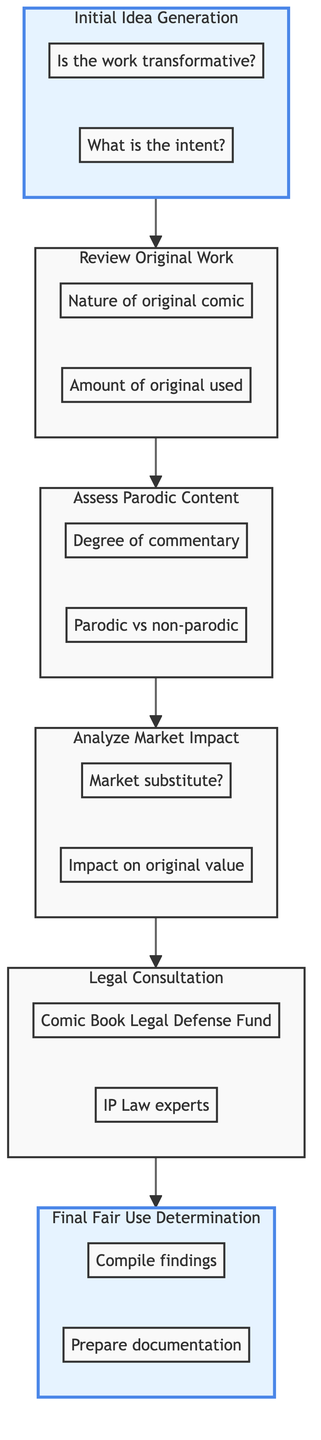What is the first stage in the fair use determination? The first stage is clearly labeled as "Initial Idea Generation" in the diagram, indicated by the arrow pointing to the next stage.
Answer: Initial Idea Generation How many stages are included in the diagram? The diagram includes six distinct stages, as indicated by the nodes connected by arrows, leading from the Initial Idea Generation to the Final Fair Use Determination.
Answer: Six What follows after the "Assess Parodic Content" stage? Based on the flow of the diagram, "Analyze Market Impact" directly follows "Assess Parodic Content", as indicated by the arrow connecting these two stages.
Answer: Analyze Market Impact Which stage includes evaluating the economic effect on the original work? The stage focused on evaluating the economic effect is "Analyze Market Impact", as it directly addresses the economic implications related to the parody work.
Answer: Analyze Market Impact What is the key question identified in the "Legal Consultation" stage? The key question pertaining to "Legal Consultation" is not explicitly stated, but it includes organizations like "Comic Book Legal Defense Fund" and professionals like "IP Law experts" which are critical in this stage.
Answer: Comic Book Legal Defense Fund What is one of the resources mentioned in the "Initial Idea Generation" stage? The resources listed under the "Initial Idea Generation" stage include insights from "Peter David" regarding parody in comic books, which is crucial for understanding this stage.
Answer: Peter David's insights What is compiled in the final stage of fair use determination? The final stage, labeled "Final Fair Use Determination", states that findings from all earlier steps need to be compiled, which is necessary for concluding the fair use analysis.
Answer: Compile findings Which sub-stage discusses the degree of comment or critique? The sub-stage that discusses the degree of comment or critique is "Assess Parodic Content", where it evaluates how the parody interacts with the original work.
Answer: Assess Parodic Content What is a critical factor analyzed immediately before seeking legal consultation? The critical factor that needs to be analyzed immediately before seeking legal consultation is the "Analyze Market Impact", as this directly laid the groundwork for legal advice that follows.
Answer: Analyze Market Impact 